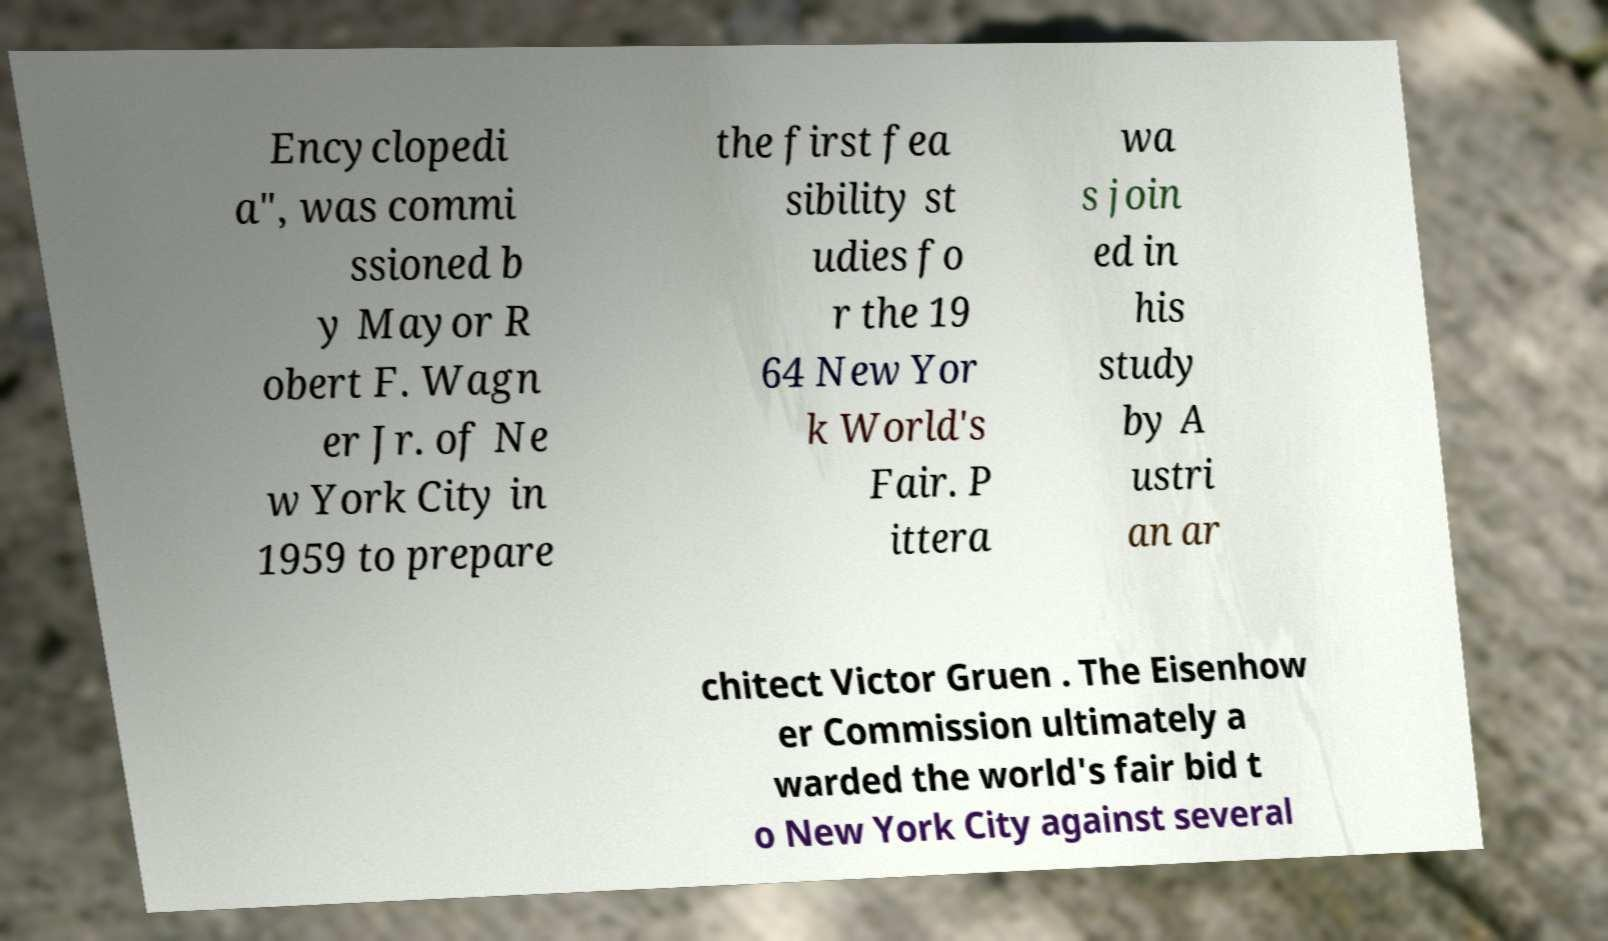There's text embedded in this image that I need extracted. Can you transcribe it verbatim? Encyclopedi a", was commi ssioned b y Mayor R obert F. Wagn er Jr. of Ne w York City in 1959 to prepare the first fea sibility st udies fo r the 19 64 New Yor k World's Fair. P ittera wa s join ed in his study by A ustri an ar chitect Victor Gruen . The Eisenhow er Commission ultimately a warded the world's fair bid t o New York City against several 